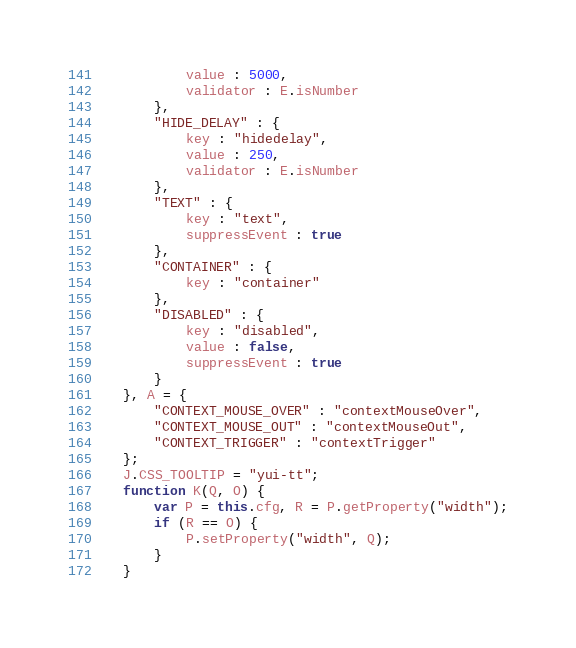<code> <loc_0><loc_0><loc_500><loc_500><_JavaScript_>			value : 5000,
			validator : E.isNumber
		},
		"HIDE_DELAY" : {
			key : "hidedelay",
			value : 250,
			validator : E.isNumber
		},
		"TEXT" : {
			key : "text",
			suppressEvent : true
		},
		"CONTAINER" : {
			key : "container"
		},
		"DISABLED" : {
			key : "disabled",
			value : false,
			suppressEvent : true
		}
	}, A = {
		"CONTEXT_MOUSE_OVER" : "contextMouseOver",
		"CONTEXT_MOUSE_OUT" : "contextMouseOut",
		"CONTEXT_TRIGGER" : "contextTrigger"
	};
	J.CSS_TOOLTIP = "yui-tt";
	function K(Q, O) {
		var P = this.cfg, R = P.getProperty("width");
		if (R == O) {
			P.setProperty("width", Q);
		}
	}</code> 